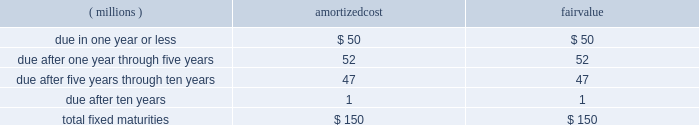Notes to consolidated financial statements the amortized cost and fair value of fixed maturities by contractual maturity as of december 31 , 2007 , are as follows : amortized fair ( millions ) cost value .
Expected maturities may differ from contractual maturities because borrowers may have the right to call or prepay obligations with or without call or prepayment penalties .
For categorization purposes , aon considers any rating of baa or higher by moody 2019s investor services or equivalent rating agency to be investment grade .
Aon 2019s continuing operations have no fixed maturities with an unrealized loss at december 31 , 2007 .
Aon 2019s fixed-maturity portfolio is subject to interest rate , market and credit risks .
With a carrying value of approximately $ 150 million at december 31 , 2007 , aon 2019s total fixed-maturity portfolio is approximately 96% ( 96 % ) investment grade based on market value .
Aon 2019s non publicly-traded fixed maturity portfolio had a carrying value of $ 9 million .
Valuations of these securities primarily reflect the fundamental analysis of the issuer and current market price of comparable securities .
Aon 2019s equity portfolio is comprised of a preferred stock not publicly traded .
This portfolio is subject to interest rate , market , credit , illiquidity , concentration and operational performance risks .
Limited partnership securitization .
In 2001 , aon sold the vast majority of its limited partnership ( lp ) portfolio , valued at $ 450 million , to peps i , a qspe .
The common stock interest in peps i is held by a limited liability company which is owned by aon ( 49% ( 49 % ) ) and by a charitable trust , which is not controlled by aon , established for victims of september 11 ( 51% ( 51 % ) ) .
Approximately $ 171 million of investment grade fixed-maturity securities were sold by peps i to unaffiliated third parties .
Peps i then paid aon 2019s insurance underwriting subsidiaries the $ 171 million in cash and issued to them an additional $ 279 million in fixed-maturity and preferred stock securities .
As part of this transaction , aon is required to purchase from peps i additional fixed-maturity securities in an amount equal to the unfunded limited partnership commitments , as they are requested .
Aon funded $ 2 million of commitments in both 2007 and 2006 .
As of december 31 , 2007 , these unfunded commitments amounted to $ 44 million .
These commitments have specific expiration dates and the general partners may decide not to draw on these commitments .
The carrying value of the peps i preferred stock was $ 168 million and $ 210 million at december 31 , 2007 and 2006 , respectively .
Prior to 2007 , income distributions received from peps i were limited to interest payments on various peps i debt instruments .
Beginning in 2007 , peps i had redeemed or collateralized all of its debt , and as a result , began to pay preferred income distributions .
In 2007 , the company received $ 61 million of income distributions from peps i , which are included in investment income .
Aon corporation .
What is the percentage of fairvalue of contracts due after ten years among the total? 
Rationale: it is the value of those contracts divided by the total , then turned into a percentage .
Computations: (1 / 150)
Answer: 0.00667. 